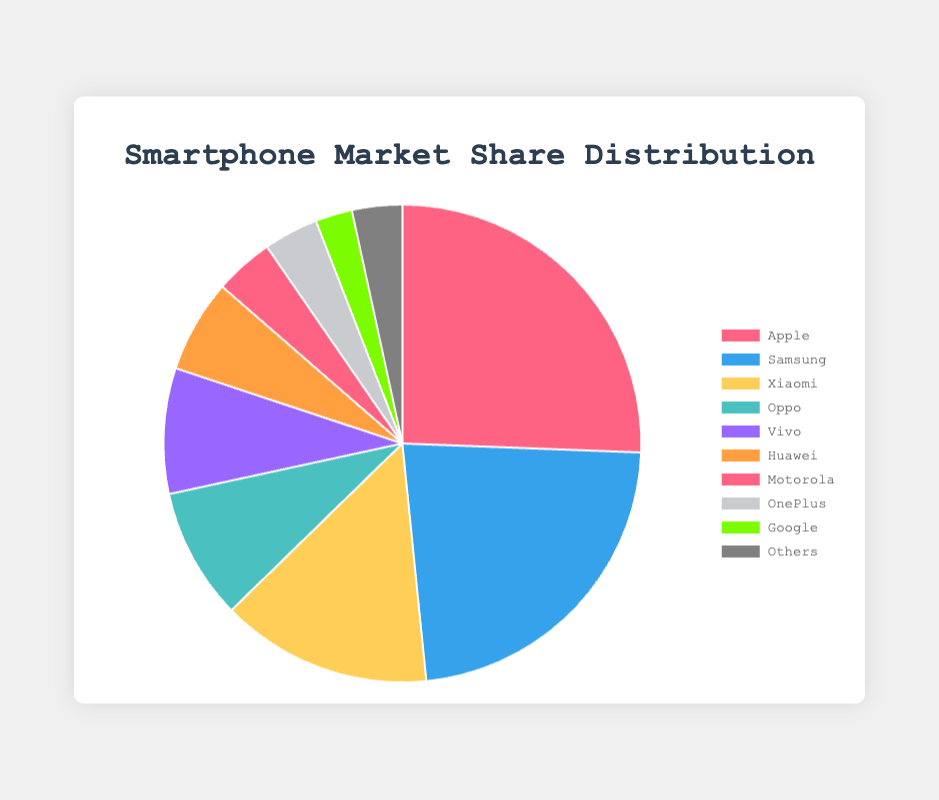What is the total market share of Apple and Samsung combined? To find the total market share of Apple and Samsung combined, add their individual market share percentages: Apple (25.6%) + Samsung (22.8%) = 48.4%
Answer: 48.4% Which brand has the third-highest market share? According to the data, the third-highest market share belongs to Xiaomi with a market share of 14.3%.
Answer: Xiaomi What is the difference in market share between Vivo and OnePlus? To find the difference in market share between Vivo and OnePlus, subtract the market share of OnePlus from Vivo: Vivo (8.5%) - OnePlus (3.7%) = 4.8%
Answer: 4.8% Which brand has a greater market share, Huawei or Motorola? According to the data, Huawei has a market share of 6.3% and Motorola has a market share of 4.0%. Thus, Huawei has a greater market share than Motorola.
Answer: Huawei What is the sum of the market shares of brands with less than 5% market share each? The brands with less than 5% market share are Motorola (4.0%), OnePlus (3.7%), and Google (2.5%). Summing these percentages: 4.0% + 3.7% + 2.5% = 10.2%.
Answer: 10.2% Which brand is represented by the blue-colored slice in the pie chart? In the pie chart, the blue-colored slice represents Samsung.
Answer: Samsung Is Oppo's market share greater than or equal to Vivo's market share? According to the data, Oppo has a market share of 8.9% and Vivo has a market share of 8.5%. Since 8.9% is greater than 8.5%, Oppo's market share is indeed greater than Vivo's.
Answer: Yes What is the average market share of the top three brands? The top three brands are Apple (25.6%), Samsung (22.8%), and Xiaomi (14.3%). To find the average, sum these percentages and divide by three: (25.6% + 22.8% + 14.3%) / 3 ≈ 20.9%.
Answer: 20.9% Which brand has a market share closest to 10%? According to the data, Oppo has a market share of 8.9%, which is closest to 10%.
Answer: Oppo 